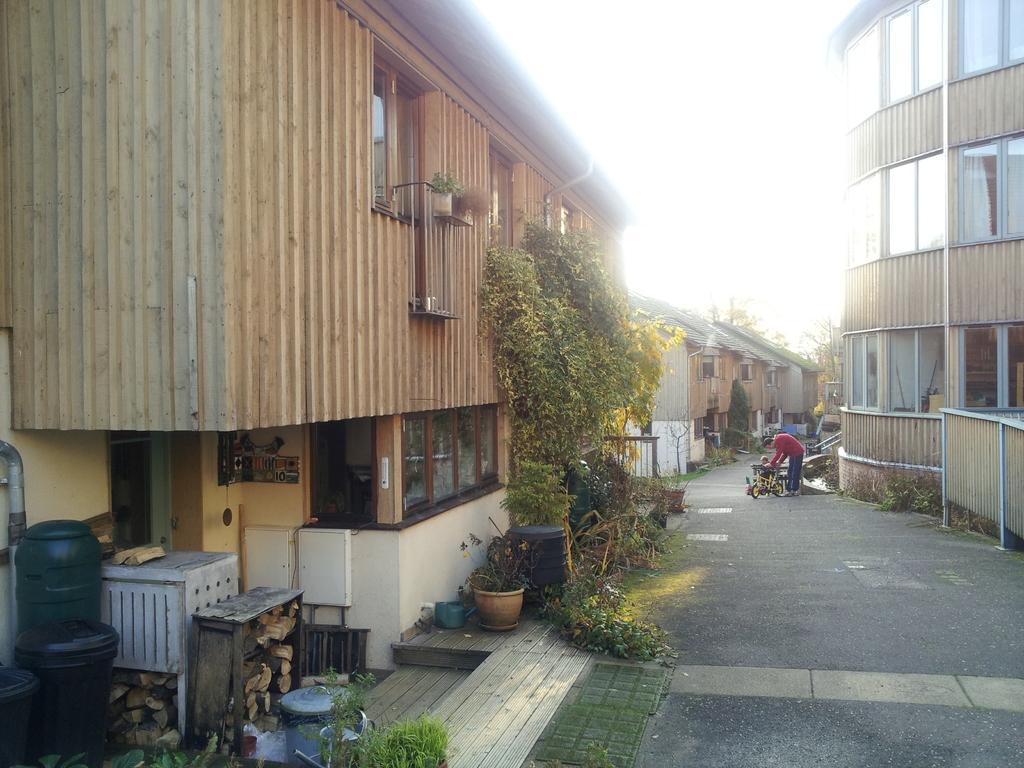Could you give a brief overview of what you see in this image? In this picture we can see people on the ground, here we can see buildings, trees, plants, houseplant, wooden logs and some objects and we can see sky in the background. 